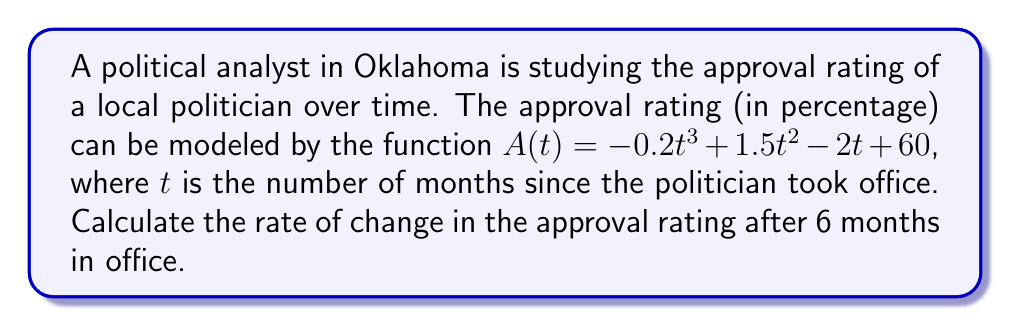Can you solve this math problem? To solve this problem, we need to follow these steps:

1) The rate of change in the approval rating is given by the derivative of the function $A(t)$.

2) Let's find the derivative of $A(t)$ using the power rule:

   $A(t) = -0.2t^3 + 1.5t^2 - 2t + 60$
   $A'(t) = -0.6t^2 + 3t - 2$

3) Now that we have the derivative, we can calculate the rate of change at $t = 6$ months:

   $A'(6) = -0.6(6)^2 + 3(6) - 2$
          $= -0.6(36) + 18 - 2$
          $= -21.6 + 18 - 2$
          $= -5.6$

4) The negative value indicates that the approval rating is decreasing at this point in time.
Answer: The rate of change in the approval rating after 6 months is $-5.6\%$ per month. 